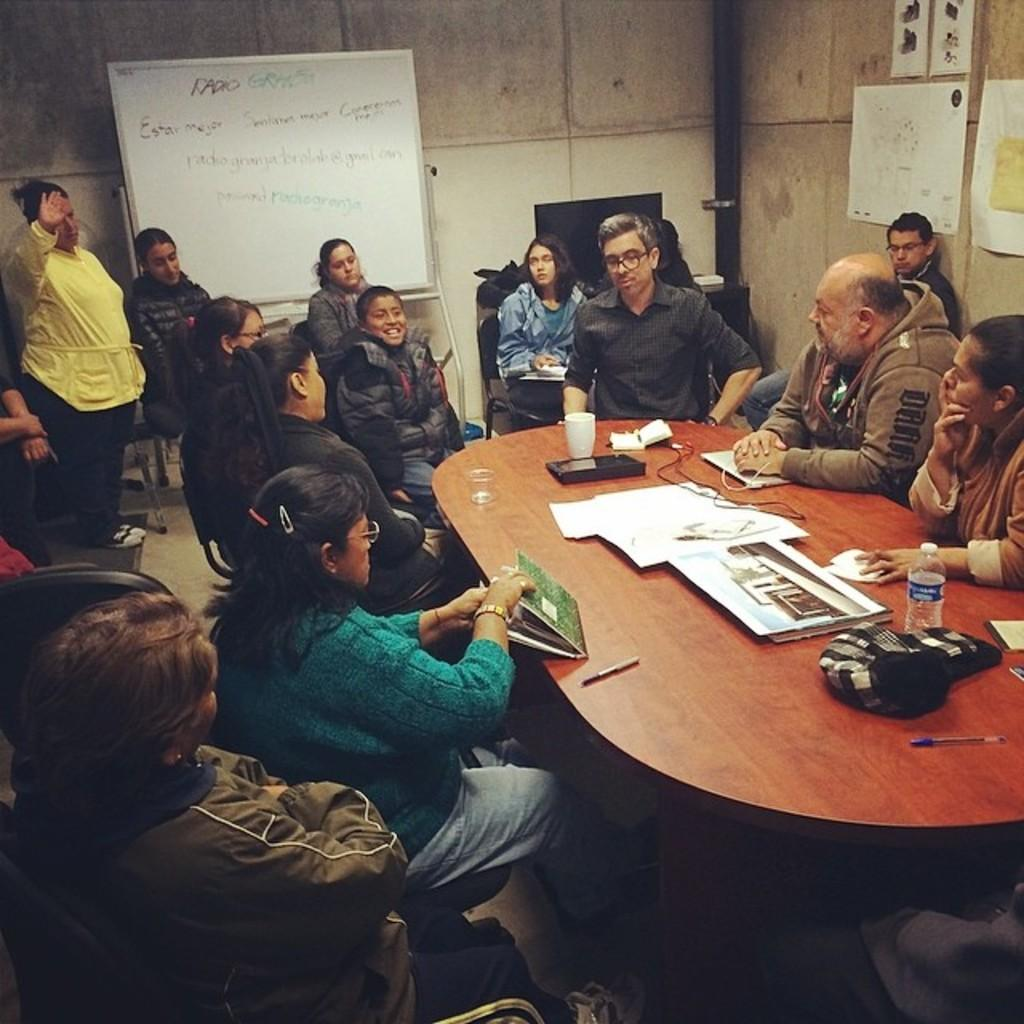What is happening in the image? There is a group of people in the image, and they are sitting around a table. What are the people doing while sitting around the table? The people are engaged in a discussion. What type of pen is being used by the person in the image? There is no pen visible in the image; the people are engaged in a discussion without any visible writing instruments. 